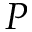Convert formula to latex. <formula><loc_0><loc_0><loc_500><loc_500>P</formula> 